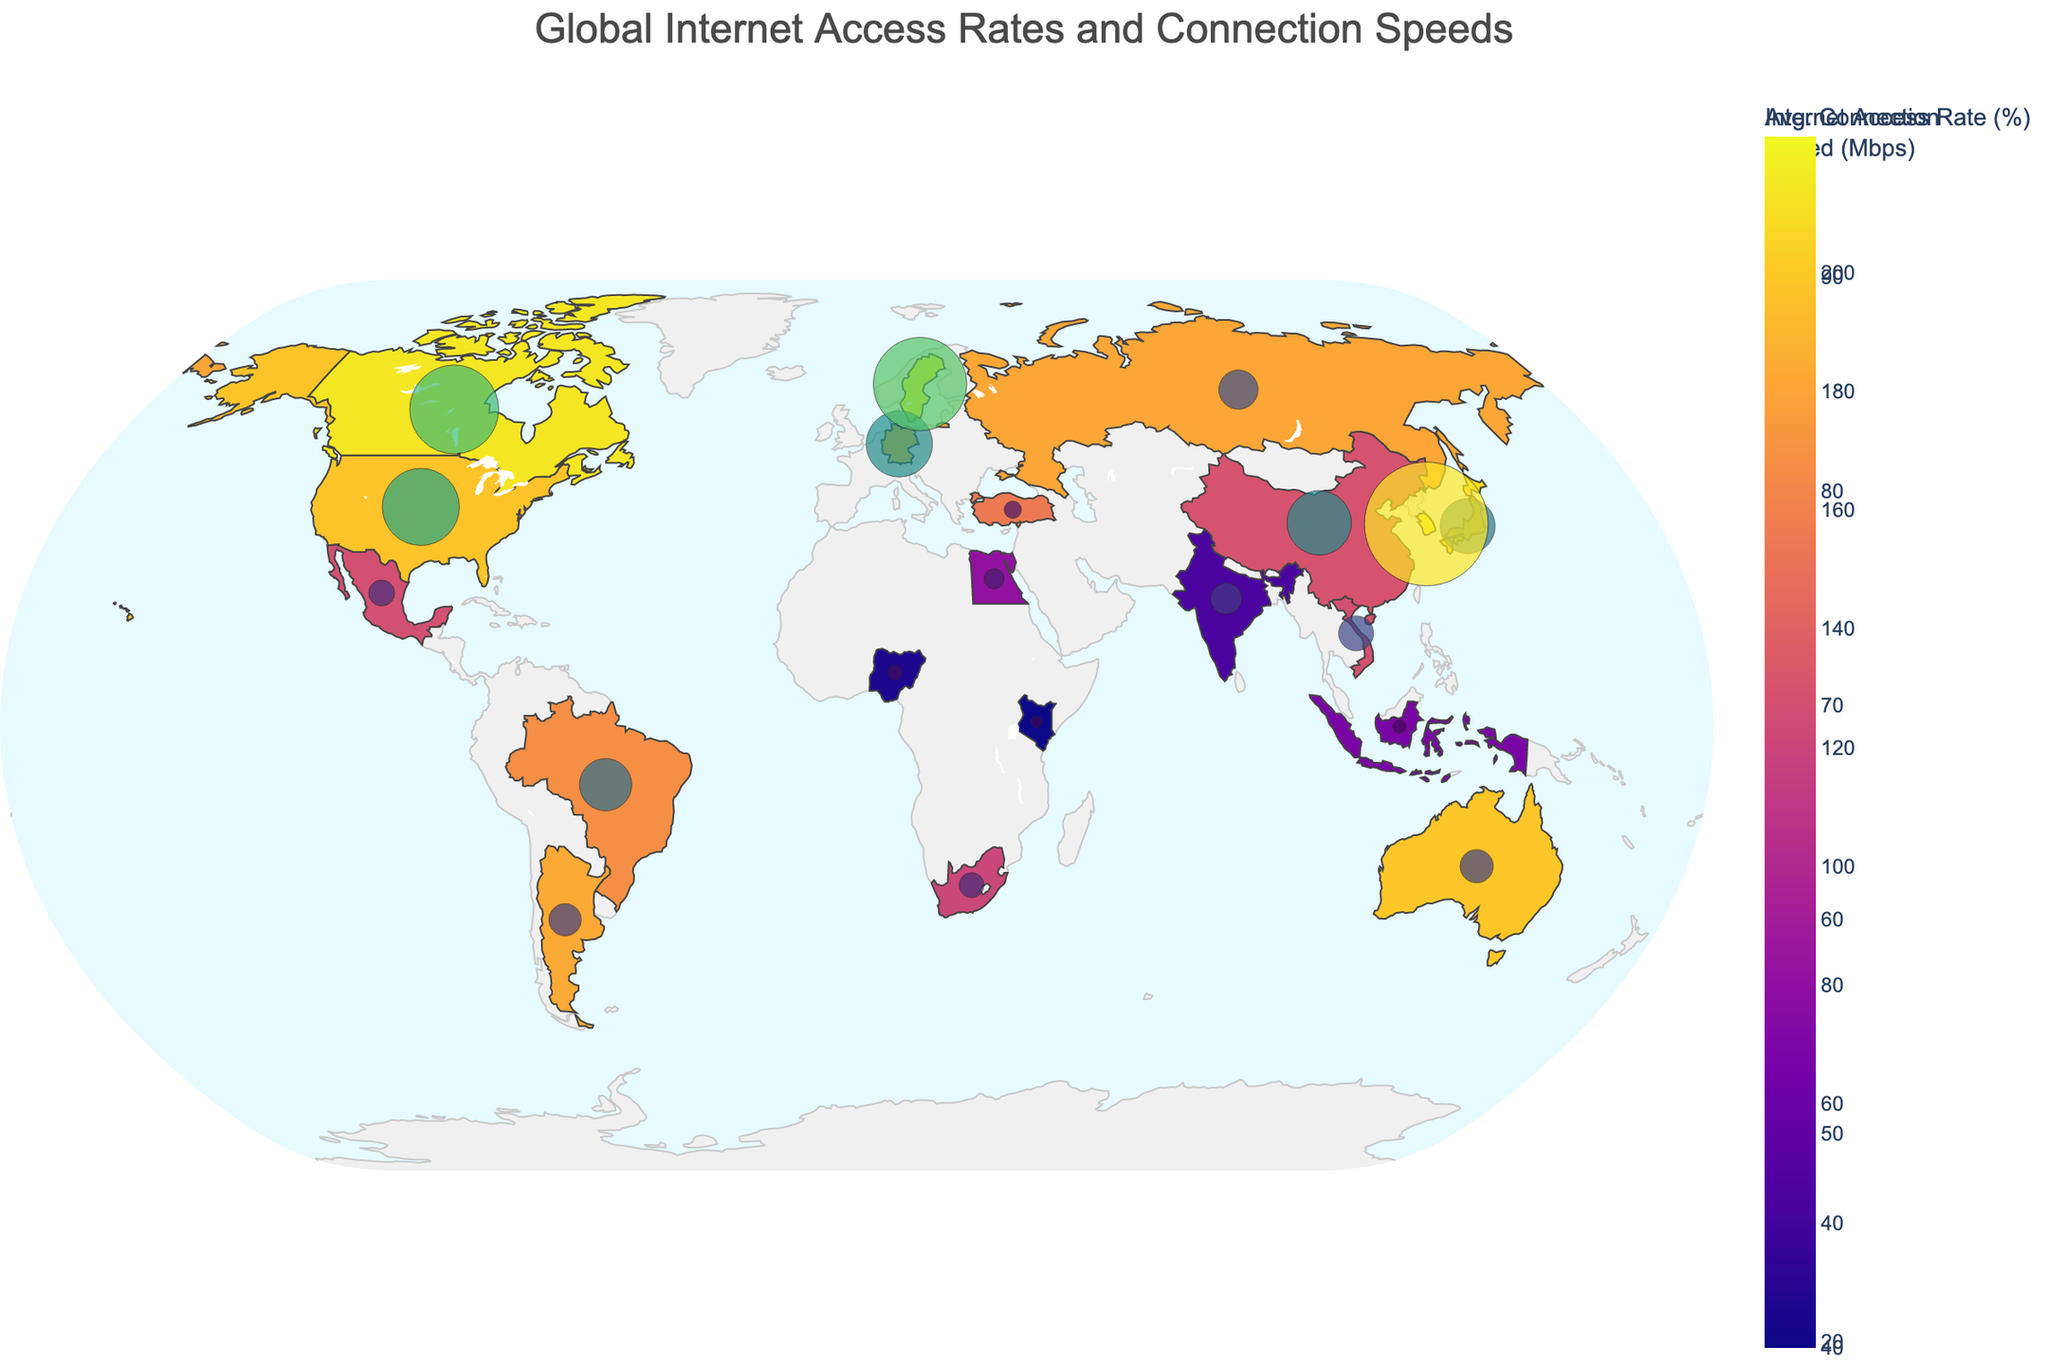Which country has the highest internet access rate? Looking at the figure, Sweden has the highest internet access rate, shown in the darkest shade on the map.
Answer: Sweden What is the relationship between internet access rate and average connection speed in South Korea? South Korea shows a very high internet access rate (96.2%) and the highest average connection speed (217.5 Mbps), indicating a strong relationship between high access rates and connection speeds in this country.
Answer: High access, high speed What is the average internet access rate among all the countries shown? To find the average, sum up all the internet access rates (89.4 + 70.6 + 47.0 + 81.3 + 42.0 + 89.8 + 53.7 + 92.7 + 85.0 + 68.2 + 96.5 + 40.0 + 89.6 + 70.1 + 57.3 + 96.2 + 94.0 + 70.3 + 77.7 + 85.5) and divide by the number of countries (20). The total is 1507.8, so the average is 1507.8 / 20 = 75.39%.
Answer: 75.39% How does Nigeria's average connection speed compare to the average global connection speed shown in the figure? To determine the average global connection speed, sum all the connection speeds (135.5 + 113.3 + 54.7 + 91.8 + 24.6 + 116.4 + 23.3 + 96.6 + 68.8 + 43.7 + 164.2 + 18.9 + 58.3 + 45.6 + 35.2 + 217.5 + 156.3 + 61.4 + 30.5 + 56.7). The total is 1613.2, divided by 20, giving an average of 80.66 Mbps. Nigeria's speed (24.6 Mbps) is much lower than this average.
Answer: Lower Which country has a high internet access rate but a relatively low average connection speed? Argentina has a high internet access rate of 85.5%, but a relatively low average connection speed of 56.7 Mbps, as shown by the discrepancy between the dark shade for access rate and the moderate bubble size for speed.
Answer: Argentina How many countries have an internet access rate above 80%? By counting the countries with access rates above 80% (United States, Germany, Japan, Brazil, Sweden, South Korea, Canada, Argentina, Russia), there are 9 such countries.
Answer: 9 Which regions or continents generally show lower internet access rates? Africa (Nigeria, Kenya, South Africa) and parts of Asia (India, Indonesia) generally show lower internet access rates, indicated by lighter shades on the map.
Answer: Africa, parts of Asia In which country is the discrepancy between internet access rate and average connection speed the most notable? South Korea has one of the highest discrepancies with near-maximum internet access rates (96.2%) and the highest connection speed (217.5 Mbps), far exceeding other countries.
Answer: South Korea Which countries have an internet access rate below 50%? The countries with internet access rates below 50% are India (47.0%), Nigeria (42.0%), and Kenya (40.0%).
Answer: India, Nigeria, Kenya Which country in the figure has the slowest average connection speed? How does its access rate compare? Kenya has the slowest average connection speed at 18.9 Mbps. Its internet access rate is also low at 40.0%, correlating low speed with low access.
Answer: Kenya, low 